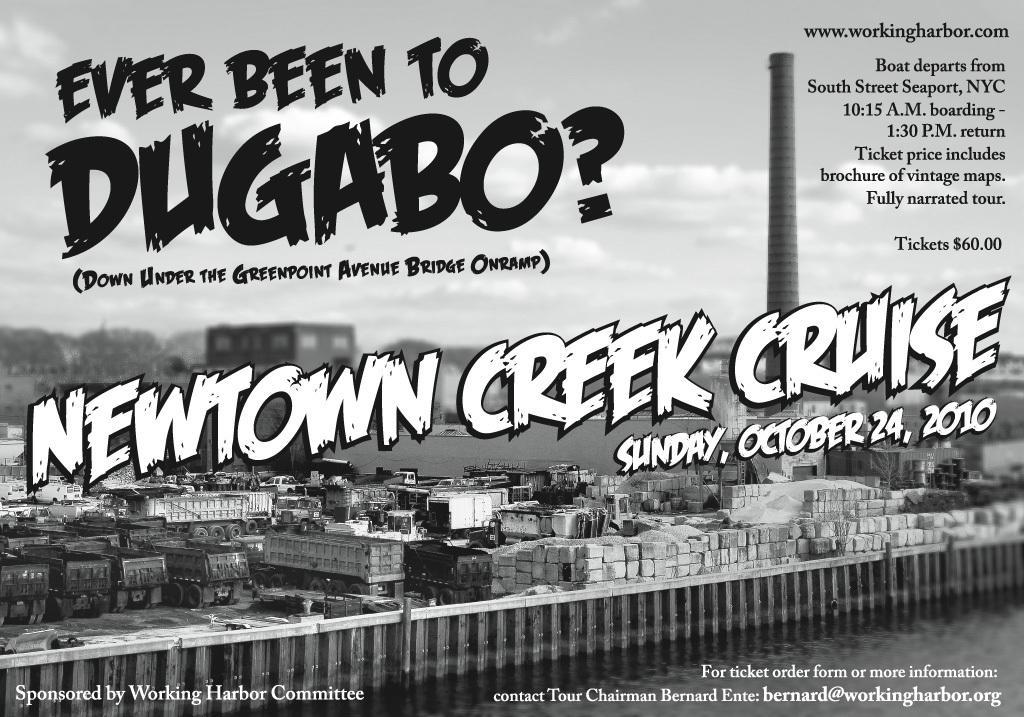Please provide a concise description of this image. In this image we can see poster of some event on which there is some text and there are some bricks, vehicles. 